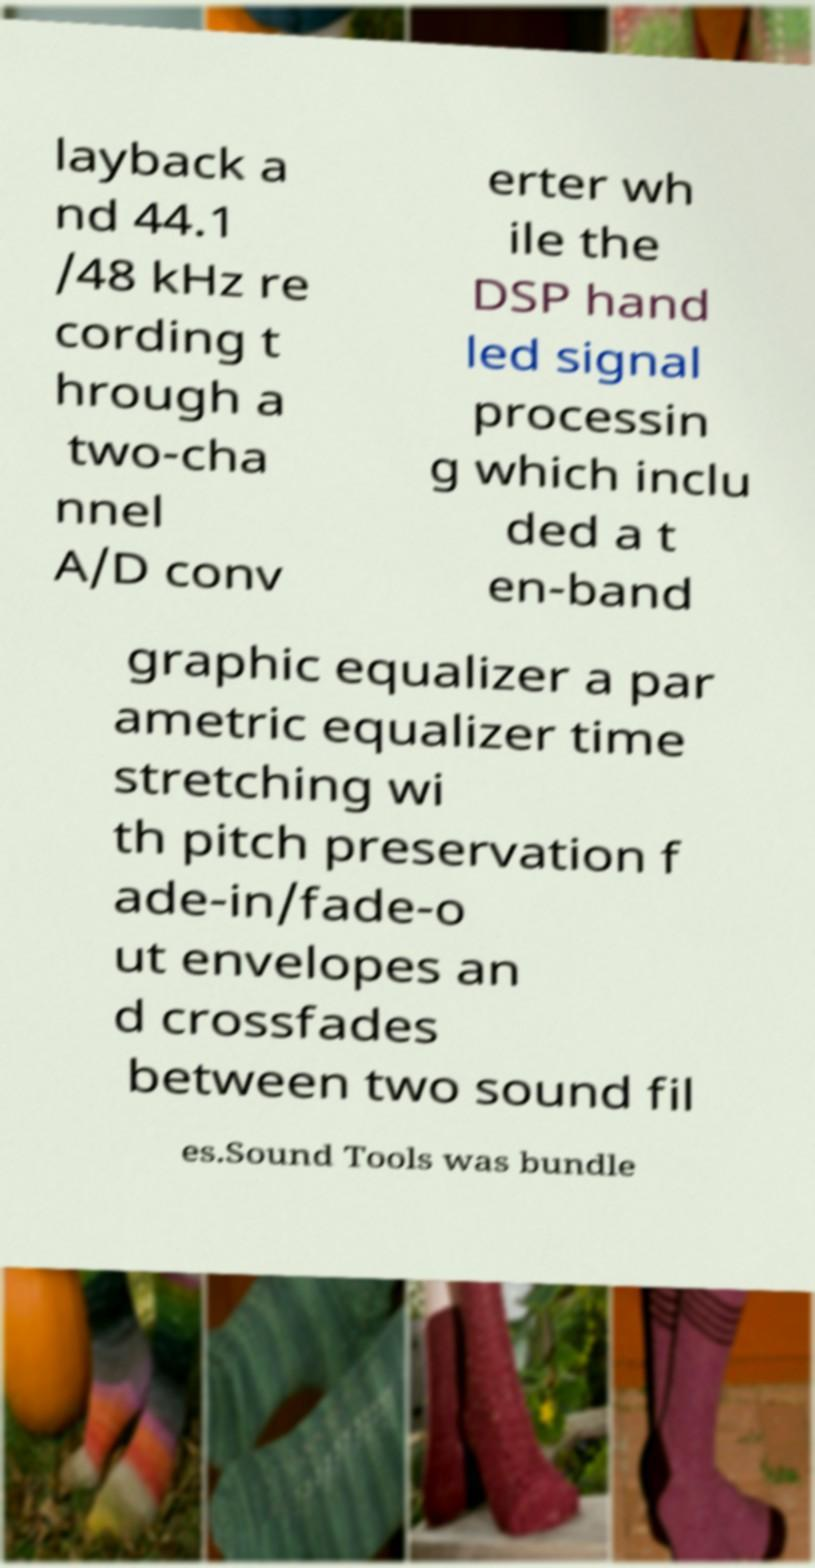Please identify and transcribe the text found in this image. layback a nd 44.1 /48 kHz re cording t hrough a two-cha nnel A/D conv erter wh ile the DSP hand led signal processin g which inclu ded a t en-band graphic equalizer a par ametric equalizer time stretching wi th pitch preservation f ade-in/fade-o ut envelopes an d crossfades between two sound fil es.Sound Tools was bundle 